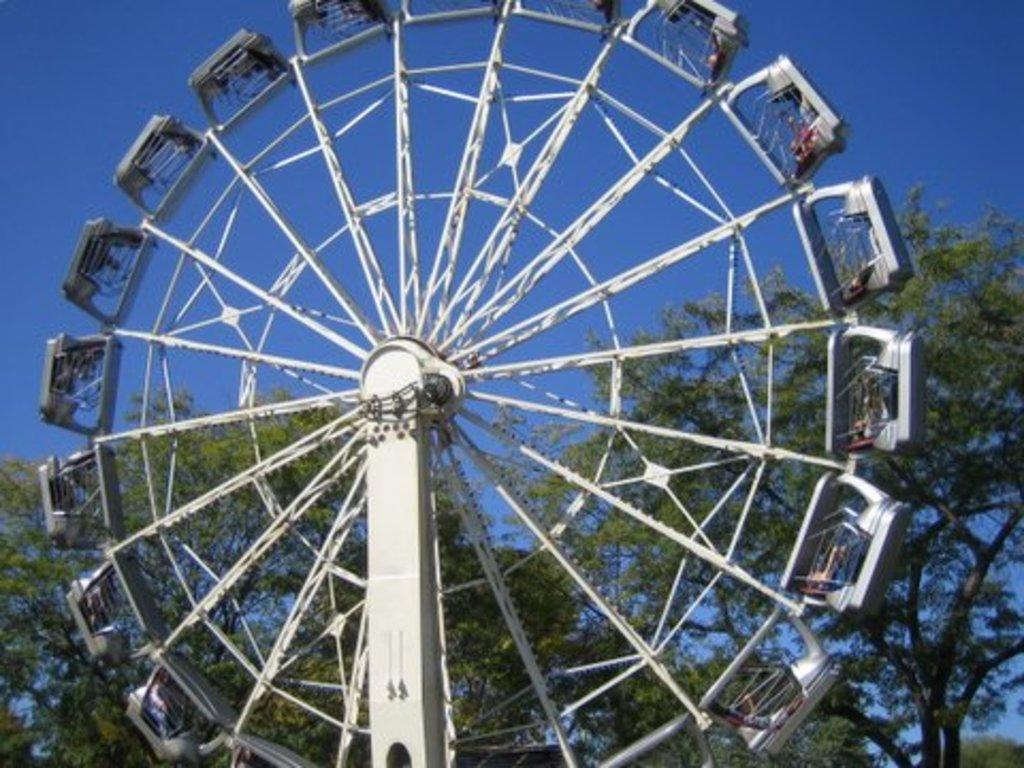What is the main structure in the image? There is a giant wheel with cabins in the image. What can be seen in the background of the image? There are trees and the sky visible in the background of the image. What type of dress is hanging on the hill in the image? There is no hill or dress present in the image. 